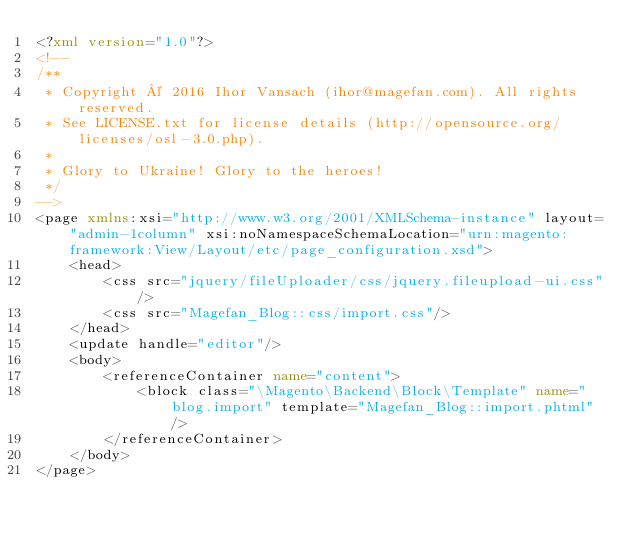Convert code to text. <code><loc_0><loc_0><loc_500><loc_500><_XML_><?xml version="1.0"?>
<!--
/**
 * Copyright © 2016 Ihor Vansach (ihor@magefan.com). All rights reserved.
 * See LICENSE.txt for license details (http://opensource.org/licenses/osl-3.0.php).
 *
 * Glory to Ukraine! Glory to the heroes!
 */
-->
<page xmlns:xsi="http://www.w3.org/2001/XMLSchema-instance" layout="admin-1column" xsi:noNamespaceSchemaLocation="urn:magento:framework:View/Layout/etc/page_configuration.xsd">
    <head>
        <css src="jquery/fileUploader/css/jquery.fileupload-ui.css"/>
        <css src="Magefan_Blog::css/import.css"/>
    </head>
    <update handle="editor"/>
    <body>
        <referenceContainer name="content">
            <block class="\Magento\Backend\Block\Template" name="blog.import" template="Magefan_Blog::import.phtml" />
        </referenceContainer>
    </body>
</page>
</code> 